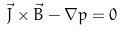<formula> <loc_0><loc_0><loc_500><loc_500>\vec { J } \times \vec { B } - \nabla p = 0</formula> 